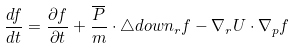<formula> <loc_0><loc_0><loc_500><loc_500>\frac { d f } { d t } = \frac { \partial f } { \partial t } + \frac { \overline { P } } { m } \cdot \triangle d o w n _ { r } f - \nabla _ { r } U \cdot \nabla _ { p } f</formula> 